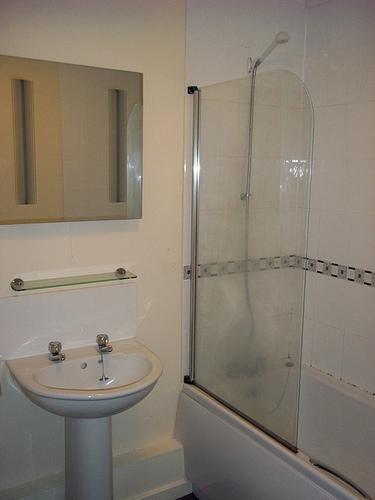How many people are there?
Give a very brief answer. 0. How many knobs on the sink are there?
Give a very brief answer. 2. 